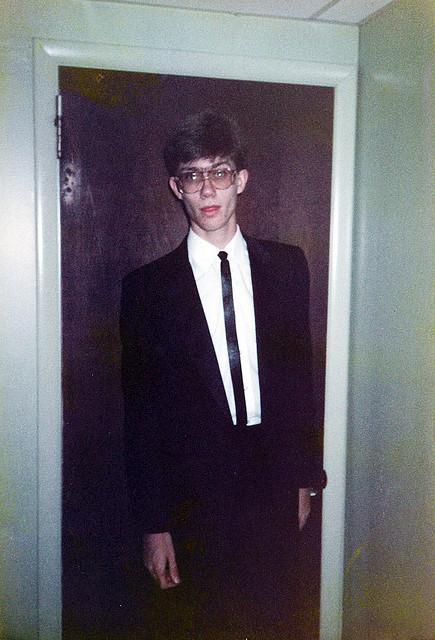Is the man skinny?
Write a very short answer. Yes. What style of tie is the man wearing?
Write a very short answer. Skinny. What color is the man's tie?
Answer briefly. Black. How tall is the man?
Write a very short answer. 6'4". 